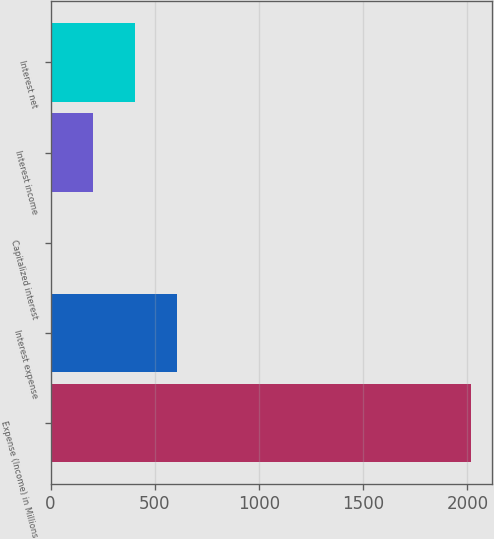Convert chart. <chart><loc_0><loc_0><loc_500><loc_500><bar_chart><fcel>Expense (Income) in Millions<fcel>Interest expense<fcel>Capitalized interest<fcel>Interest income<fcel>Interest net<nl><fcel>2017<fcel>608.32<fcel>4.6<fcel>205.84<fcel>407.08<nl></chart> 